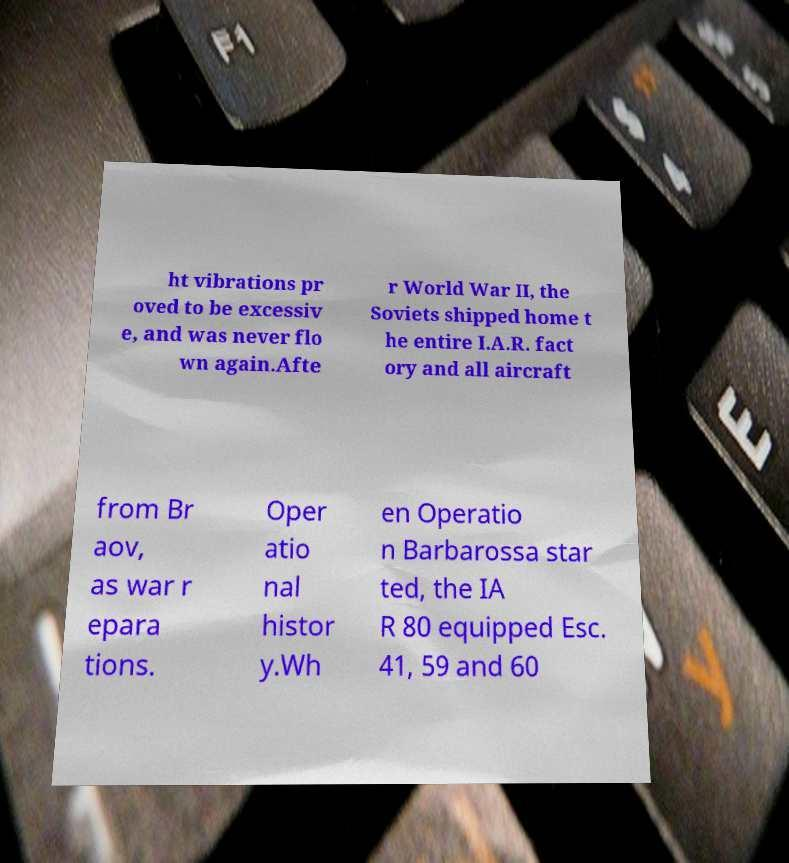I need the written content from this picture converted into text. Can you do that? ht vibrations pr oved to be excessiv e, and was never flo wn again.Afte r World War II, the Soviets shipped home t he entire I.A.R. fact ory and all aircraft from Br aov, as war r epara tions. Oper atio nal histor y.Wh en Operatio n Barbarossa star ted, the IA R 80 equipped Esc. 41, 59 and 60 